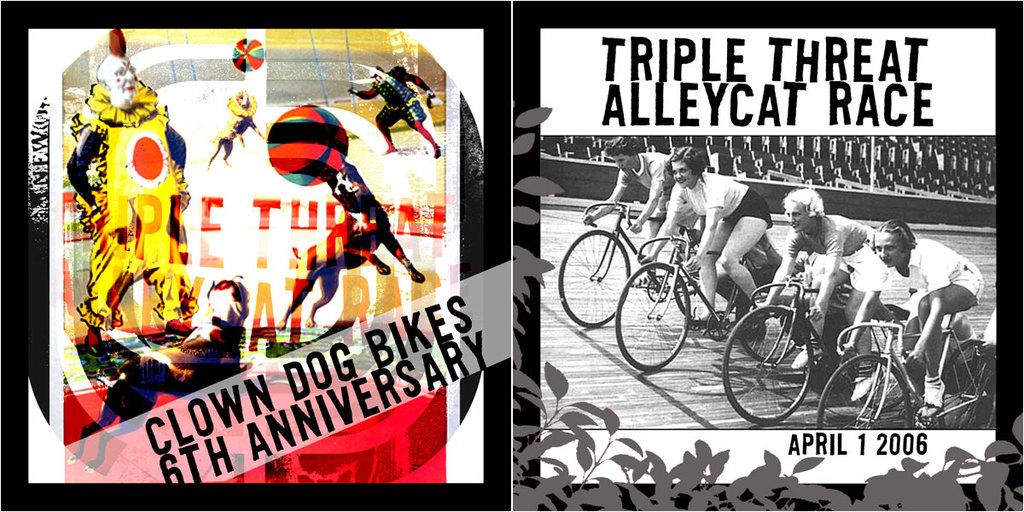What kind of race is mentioned on the right?
Keep it short and to the point. Triple threat alleycat. What is the anniversary for clown dog bikes?
Your answer should be compact. 6th. 